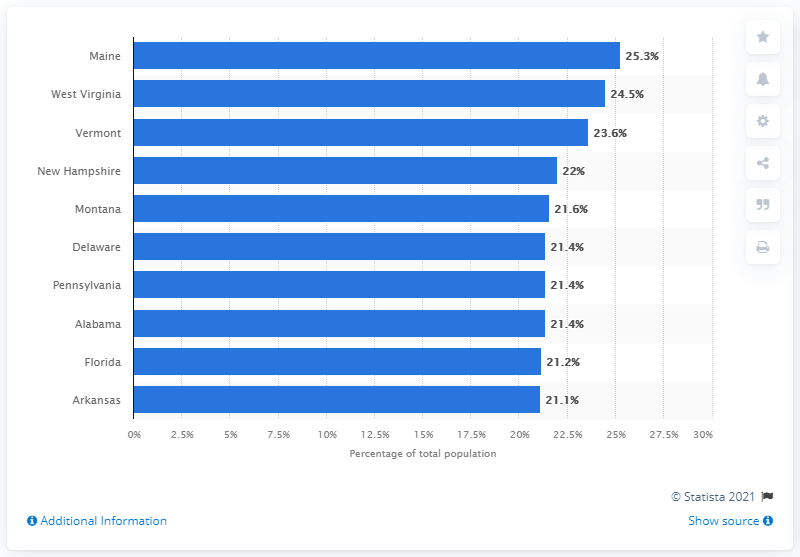Highlight a few significant elements in this photo. Maine had the highest percentage of Medicare beneficiaries in 2019 among all the states in the United States. 